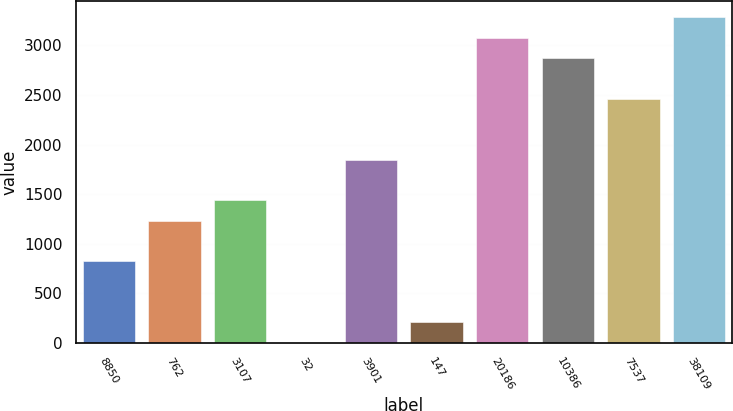<chart> <loc_0><loc_0><loc_500><loc_500><bar_chart><fcel>8850<fcel>762<fcel>3107<fcel>32<fcel>3901<fcel>147<fcel>20186<fcel>10386<fcel>7537<fcel>38109<nl><fcel>822.4<fcel>1232.6<fcel>1437.7<fcel>2<fcel>1847.9<fcel>207.1<fcel>3078.5<fcel>2873.4<fcel>2463.2<fcel>3283.6<nl></chart> 